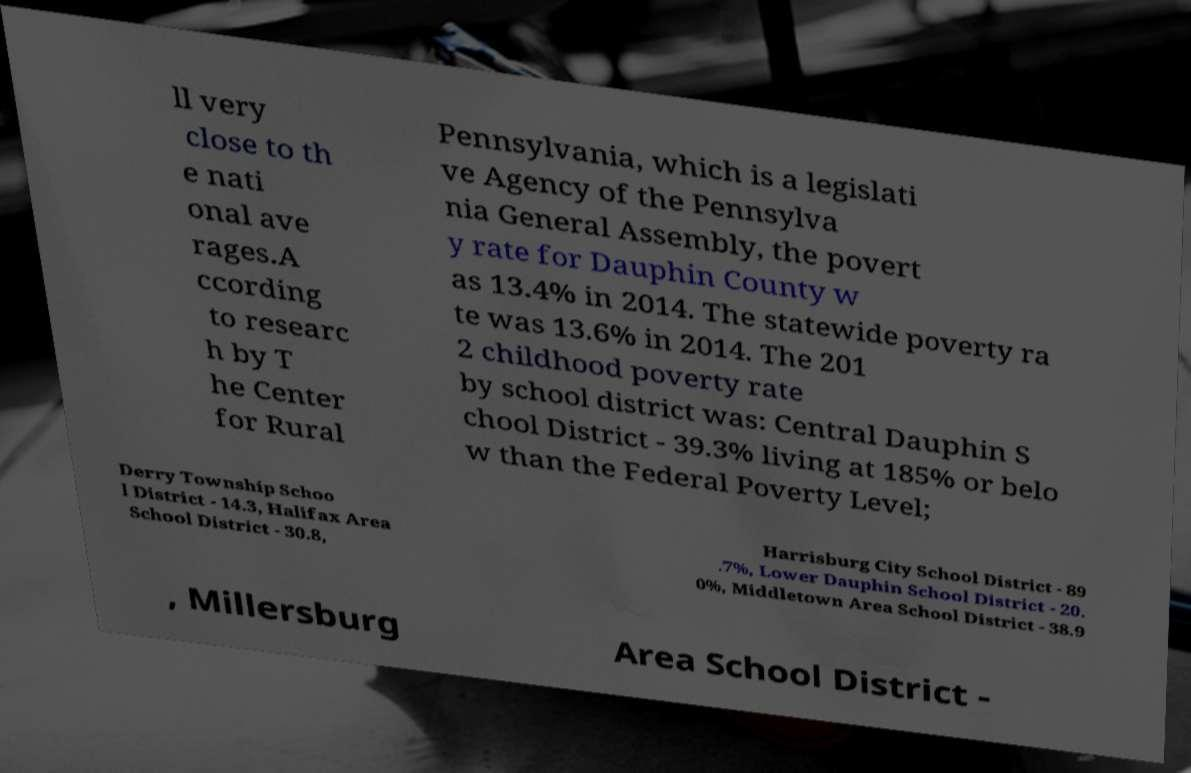Can you accurately transcribe the text from the provided image for me? ll very close to th e nati onal ave rages.A ccording to researc h by T he Center for Rural Pennsylvania, which is a legislati ve Agency of the Pennsylva nia General Assembly, the povert y rate for Dauphin County w as 13.4% in 2014. The statewide poverty ra te was 13.6% in 2014. The 201 2 childhood poverty rate by school district was: Central Dauphin S chool District - 39.3% living at 185% or belo w than the Federal Poverty Level; Derry Township Schoo l District - 14.3, Halifax Area School District - 30.8, Harrisburg City School District - 89 .7%, Lower Dauphin School District - 20. 0%, Middletown Area School District - 38.9 , Millersburg Area School District - 